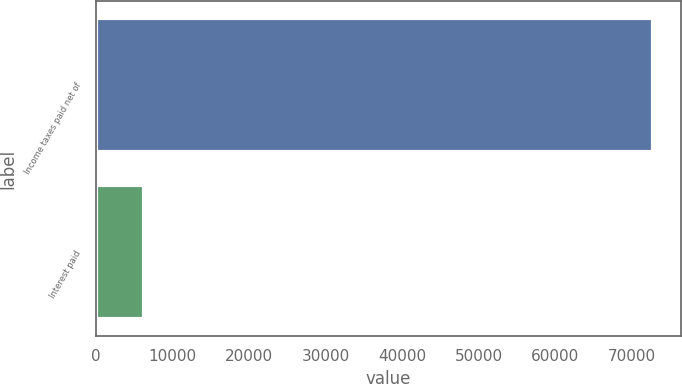Convert chart. <chart><loc_0><loc_0><loc_500><loc_500><bar_chart><fcel>Income taxes paid net of<fcel>Interest paid<nl><fcel>72827<fcel>6339<nl></chart> 